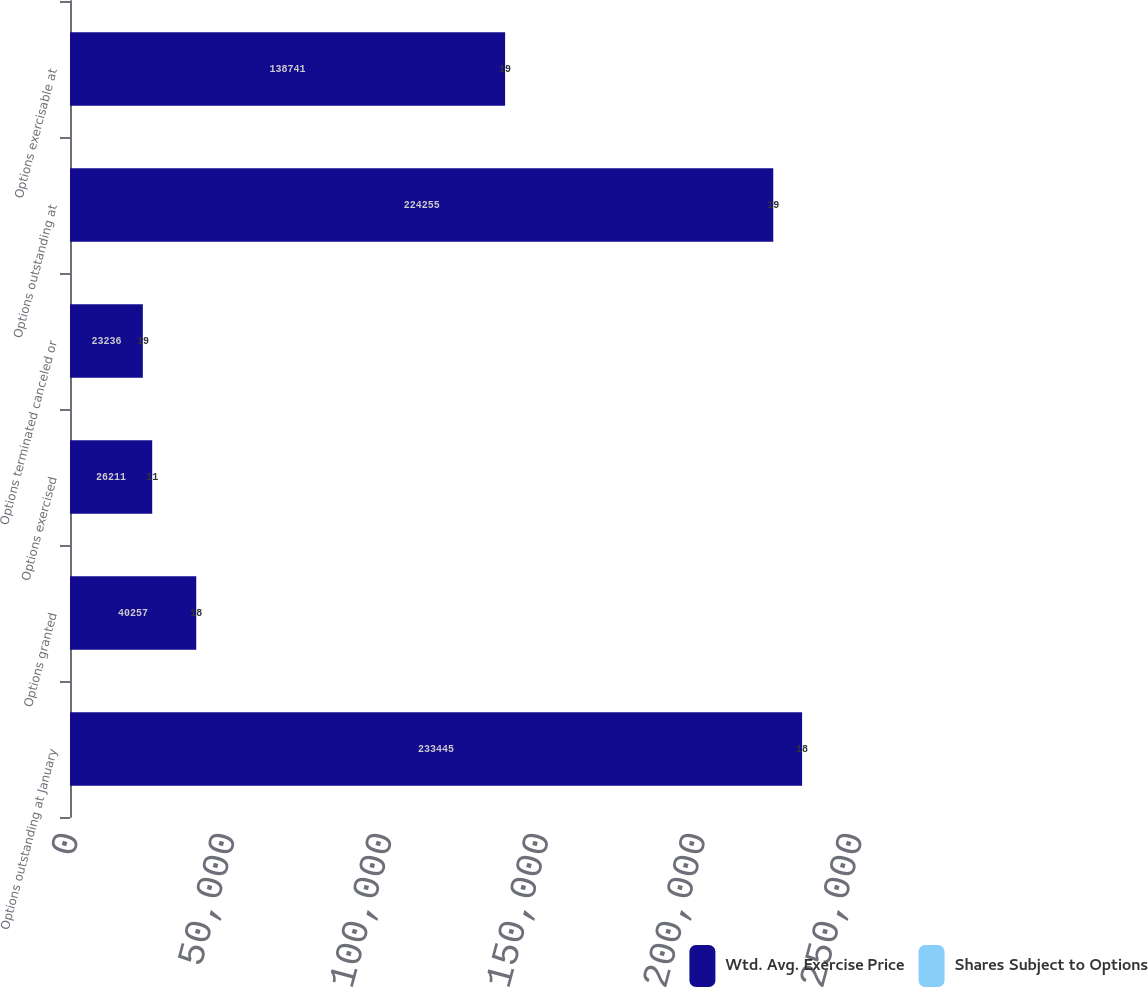Convert chart to OTSL. <chart><loc_0><loc_0><loc_500><loc_500><stacked_bar_chart><ecel><fcel>Options outstanding at January<fcel>Options granted<fcel>Options exercised<fcel>Options terminated canceled or<fcel>Options outstanding at<fcel>Options exercisable at<nl><fcel>Wtd. Avg. Exercise Price<fcel>233445<fcel>40257<fcel>26211<fcel>23236<fcel>224255<fcel>138741<nl><fcel>Shares Subject to Options<fcel>18<fcel>18<fcel>11<fcel>19<fcel>19<fcel>19<nl></chart> 